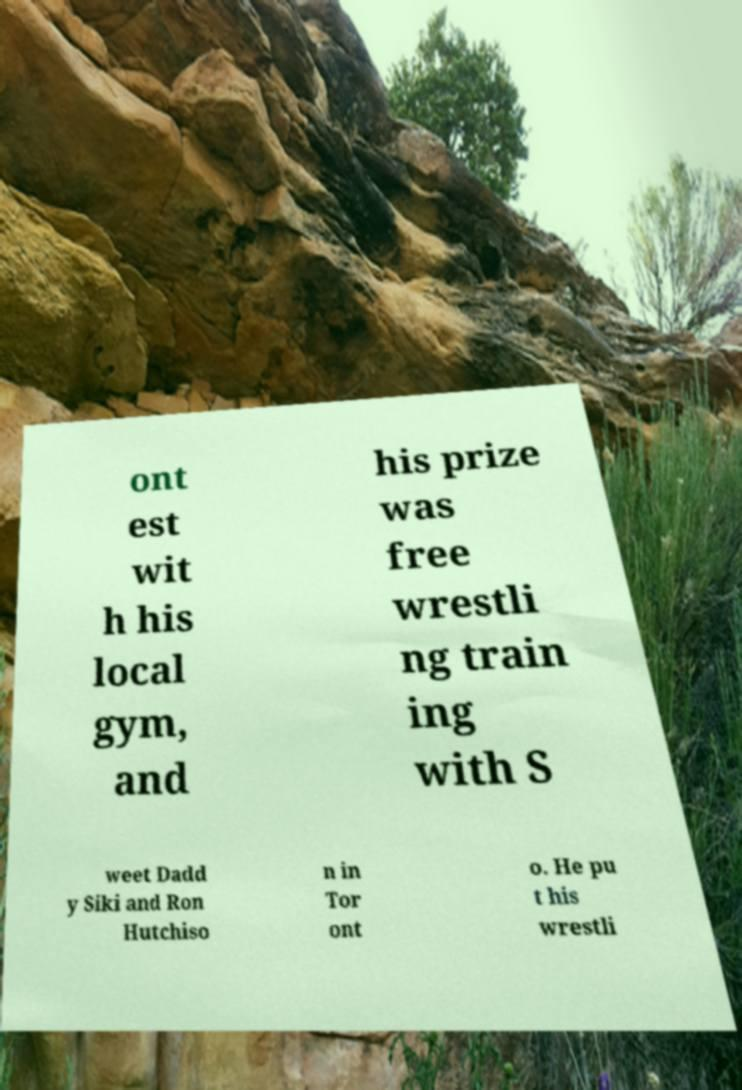Could you extract and type out the text from this image? ont est wit h his local gym, and his prize was free wrestli ng train ing with S weet Dadd y Siki and Ron Hutchiso n in Tor ont o. He pu t his wrestli 